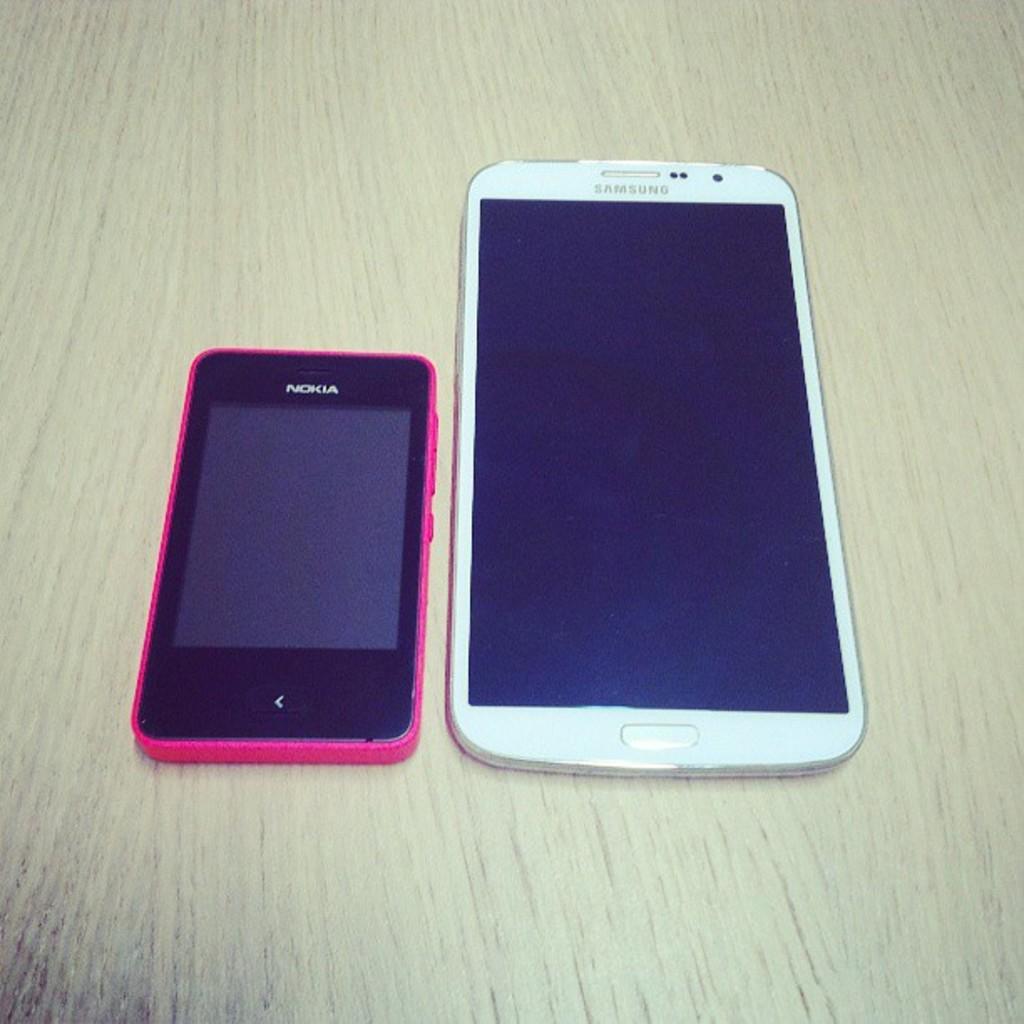What brand of phone is the pink phone?
Provide a short and direct response. Nokia. What brand of phone is the white phone?
Offer a very short reply. Samsung. 